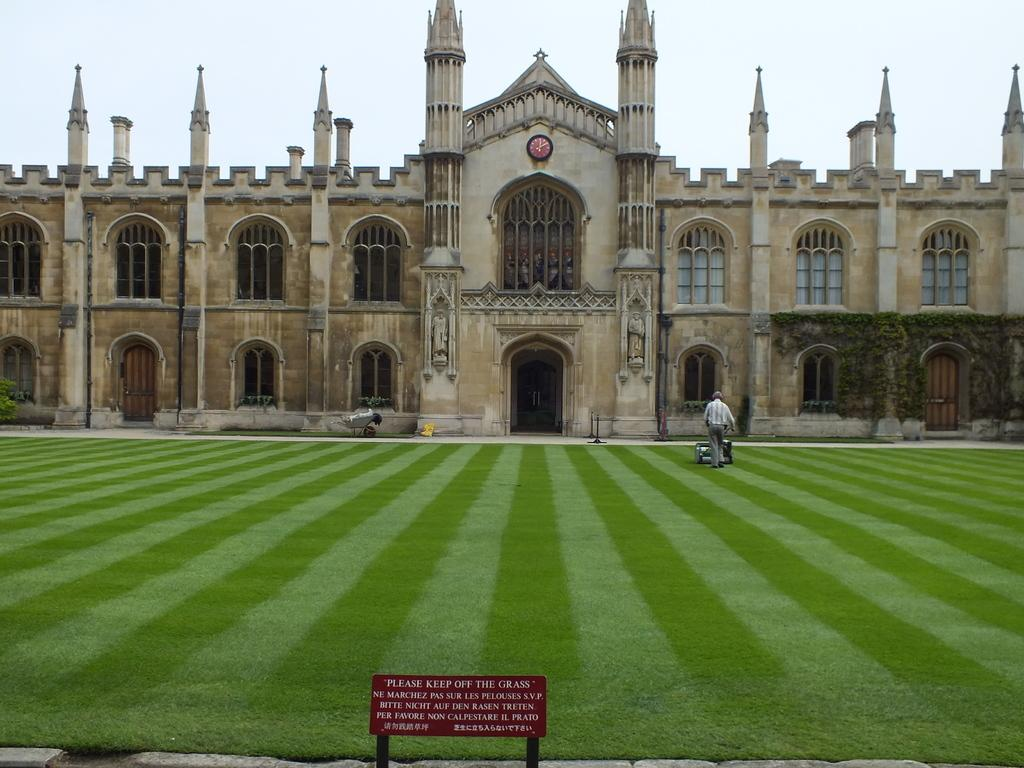What is the main structure in the image? There is a big building in the image. Can you describe the person in the image? The person is cutting grass with a machine. What activity is the person performing? The person is cutting grass with a machine. How many cherries are on the dog in the image? There is no dog or cherries present in the image. 